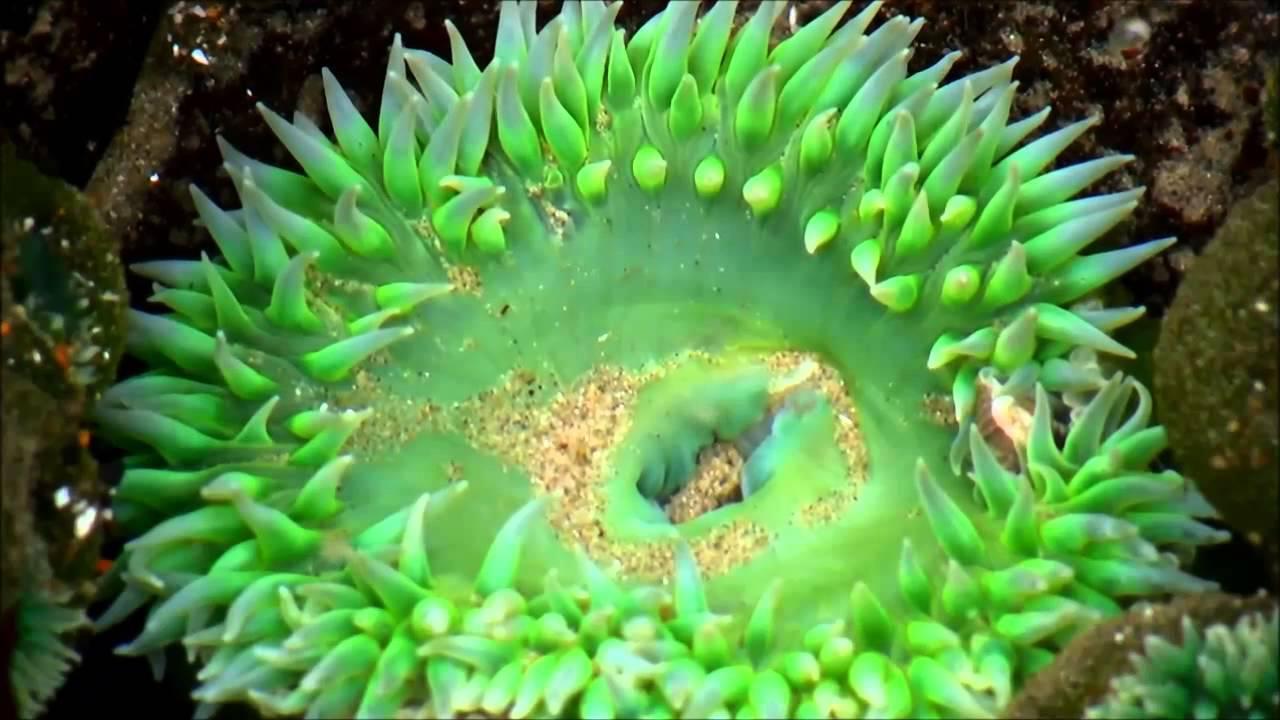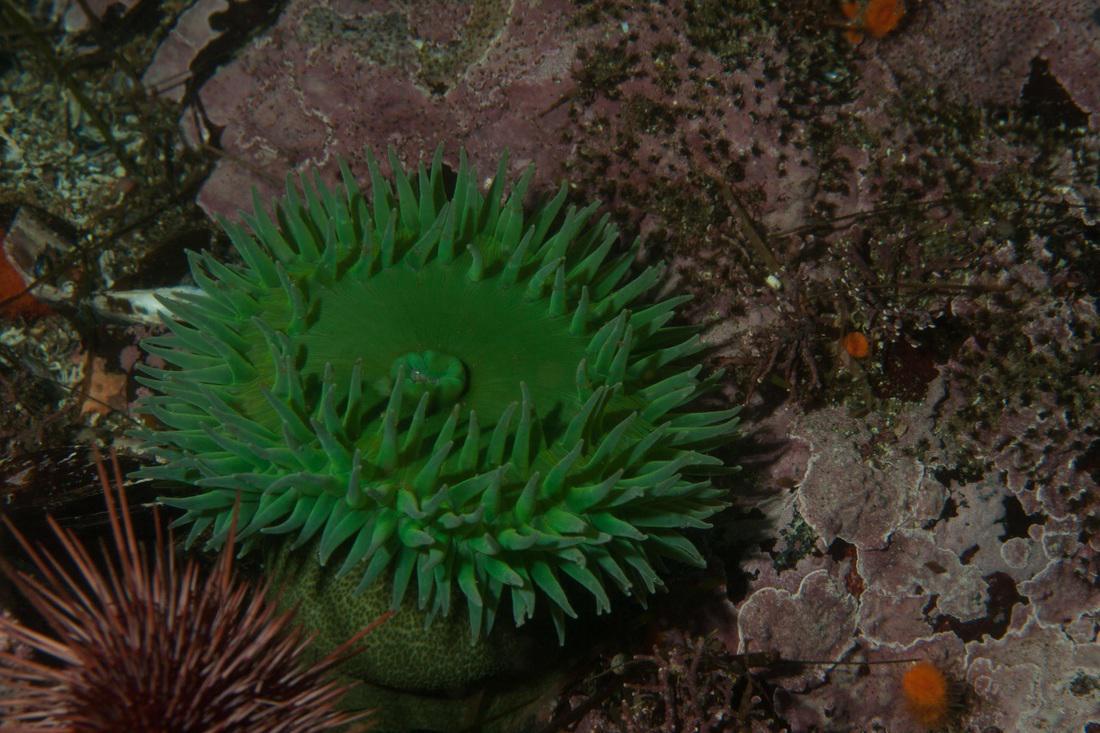The first image is the image on the left, the second image is the image on the right. Examine the images to the left and right. Is the description "There are more sea organisms in the image on the left." accurate? Answer yes or no. No. The first image is the image on the left, the second image is the image on the right. Given the left and right images, does the statement "Each image features lime-green anemone with tapered tendrils, and at least one image contains a single lime-green anemone." hold true? Answer yes or no. Yes. 